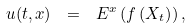<formula> <loc_0><loc_0><loc_500><loc_500>u ( t , x ) \ = \ E ^ { x } \left ( f \left ( X _ { t } \right ) \right ) ,</formula> 